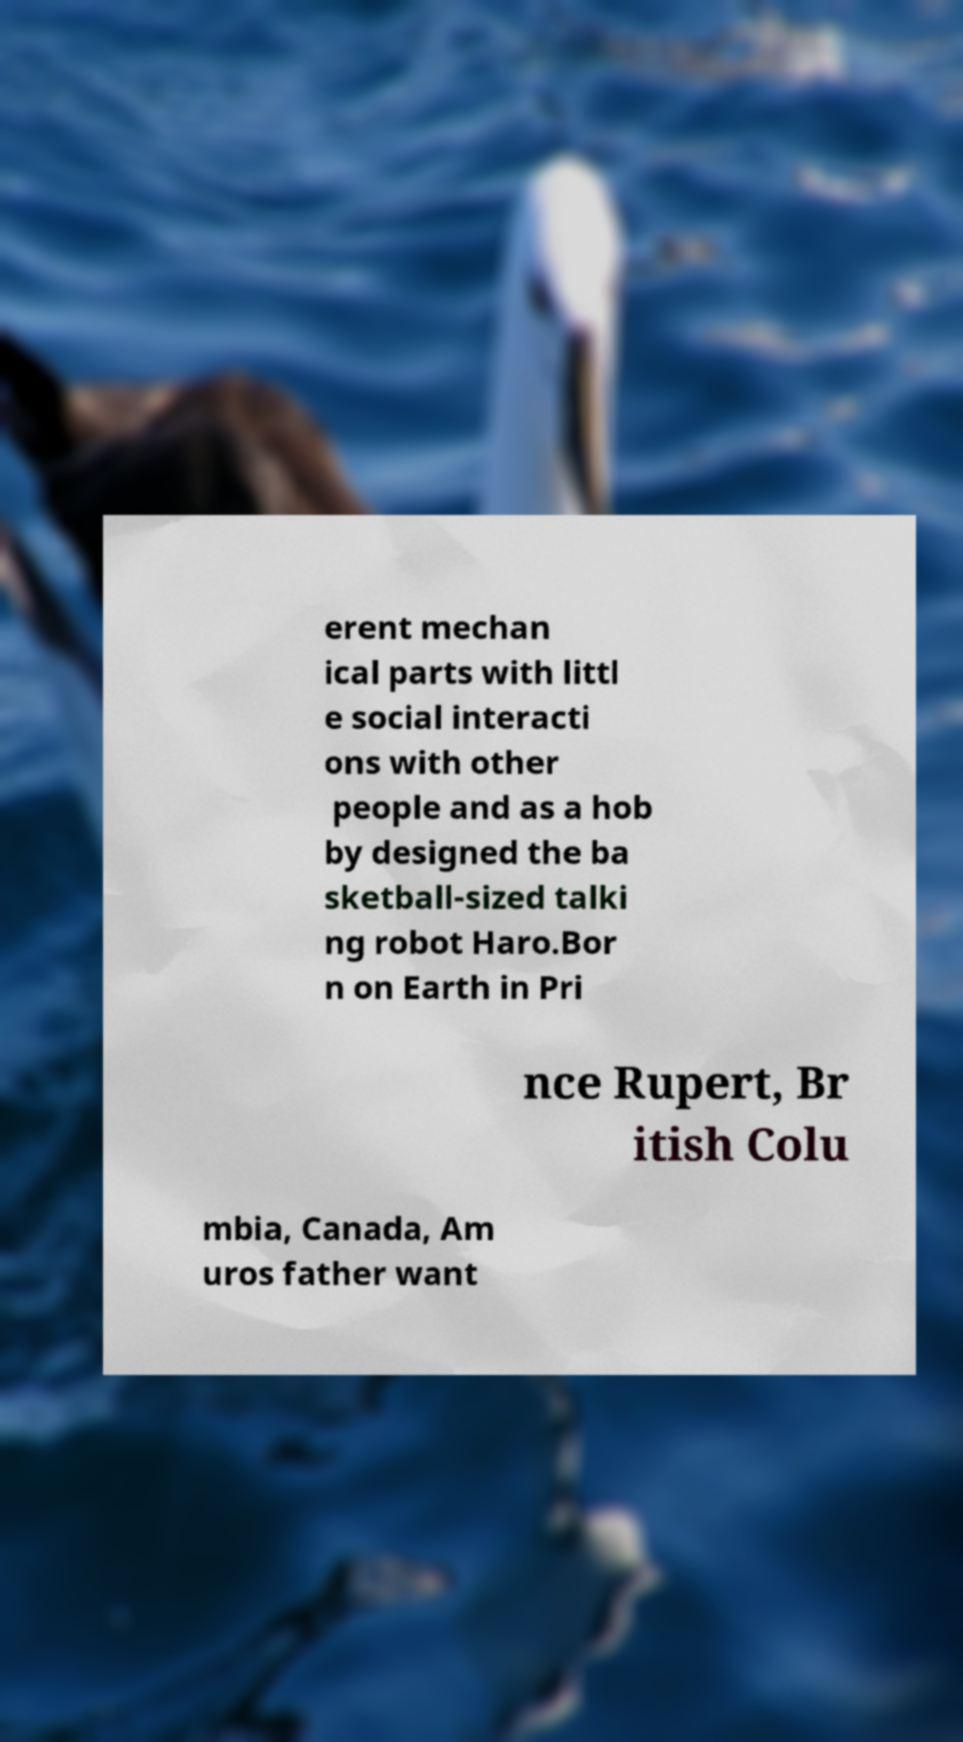What messages or text are displayed in this image? I need them in a readable, typed format. erent mechan ical parts with littl e social interacti ons with other people and as a hob by designed the ba sketball-sized talki ng robot Haro.Bor n on Earth in Pri nce Rupert, Br itish Colu mbia, Canada, Am uros father want 